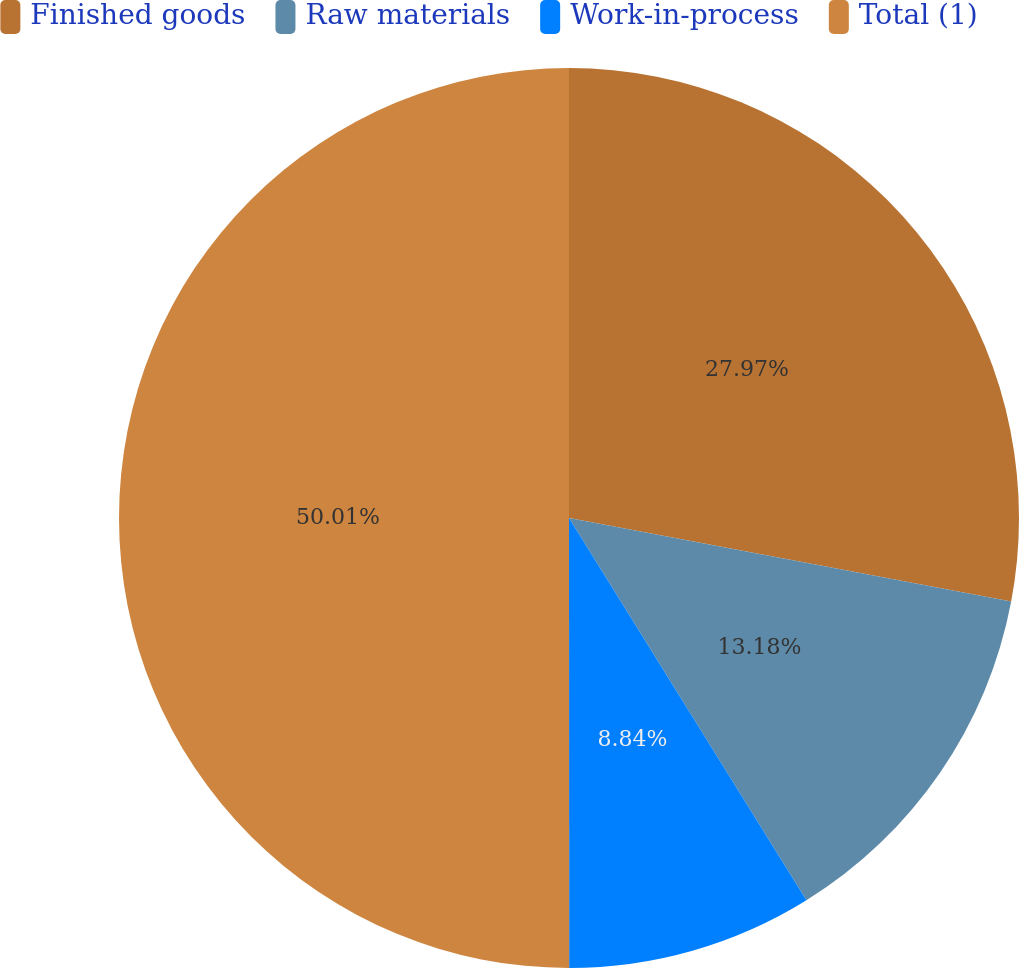Convert chart. <chart><loc_0><loc_0><loc_500><loc_500><pie_chart><fcel>Finished goods<fcel>Raw materials<fcel>Work-in-process<fcel>Total (1)<nl><fcel>27.97%<fcel>13.18%<fcel>8.84%<fcel>50.0%<nl></chart> 